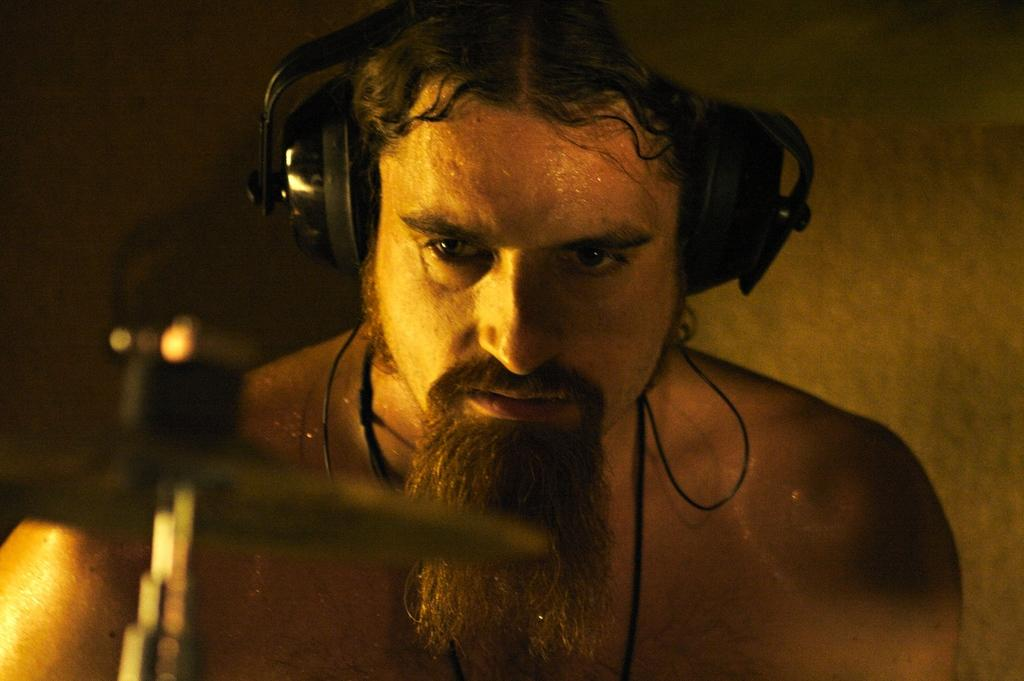What is the main subject of the image? There is a man in the image. What is the man wearing in the image? The man is wearing headphones. What can be seen connected to the headphones in the image? There are black wires visible in the image. What is visible in the background of the image? There is a wall in the background of the image. What type of plants can be seen growing on the wall in the image? There are no plants visible on the wall in the image. How does the man blow air into the headphones in the image? The man is not blowing air into the headphones in the image; he is simply wearing them. 